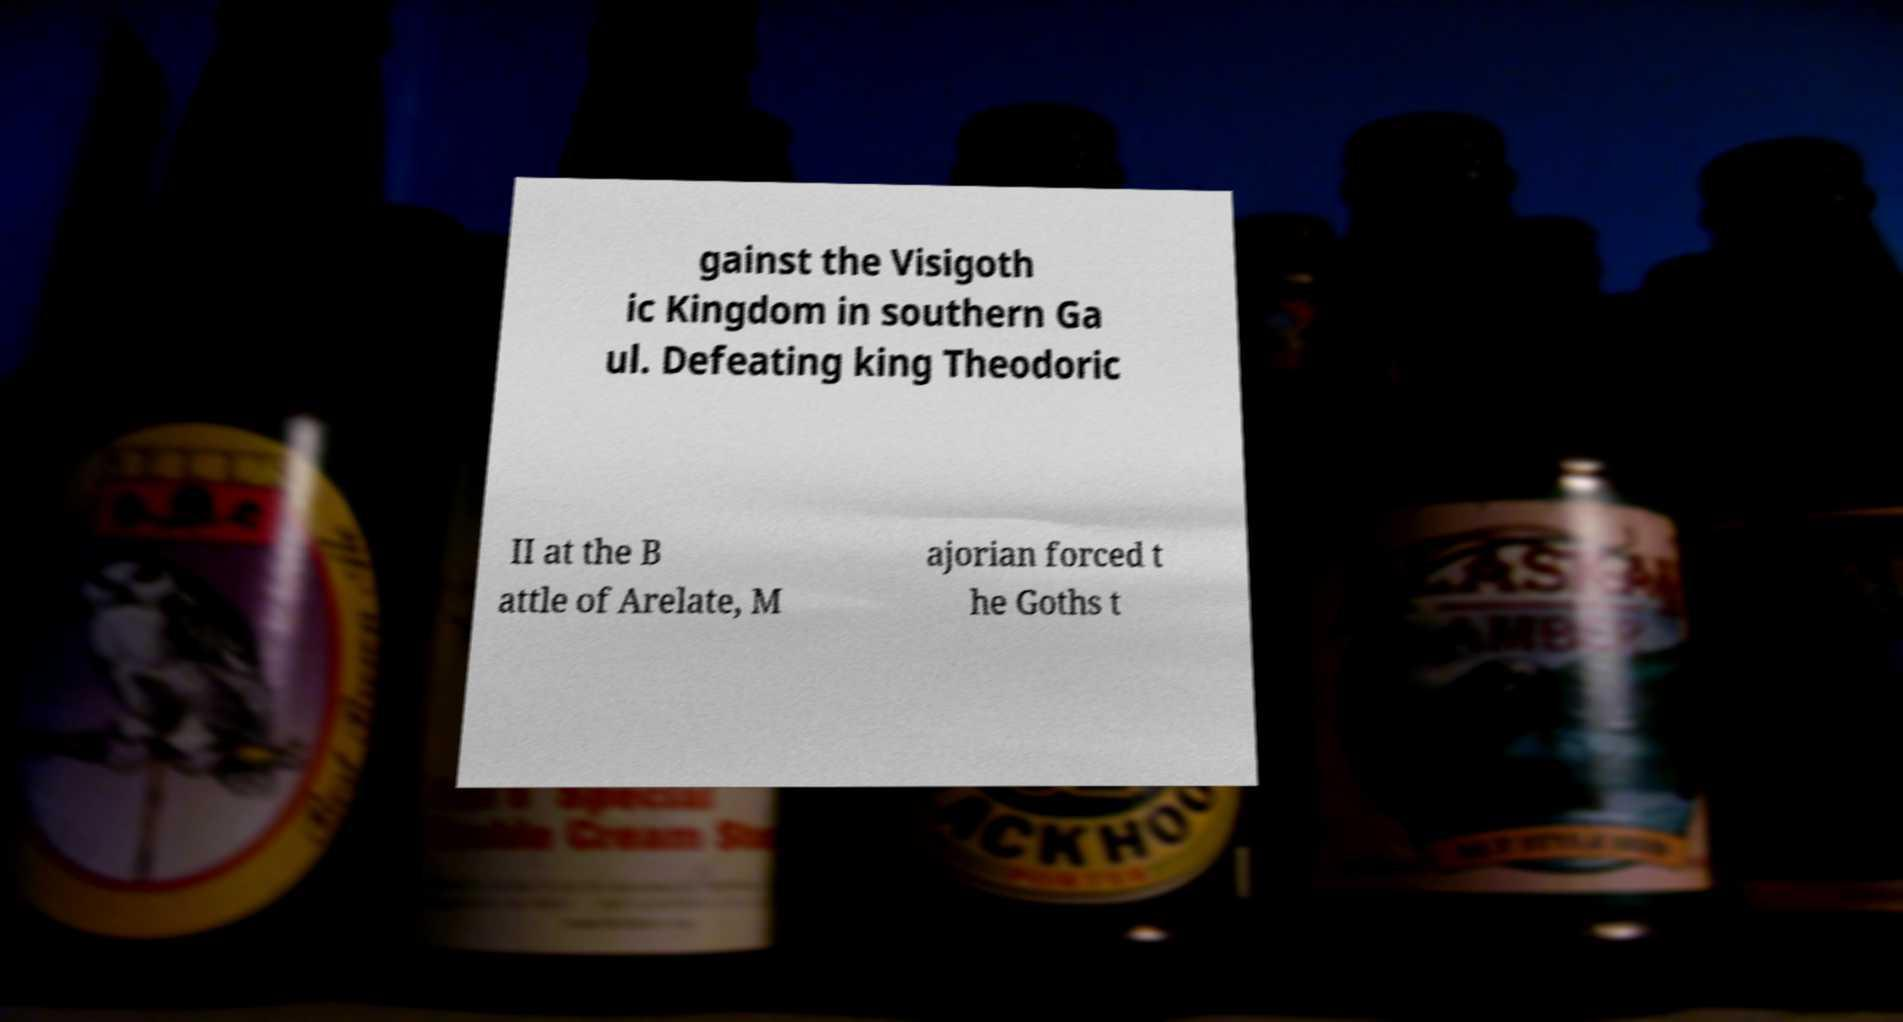Please read and relay the text visible in this image. What does it say? gainst the Visigoth ic Kingdom in southern Ga ul. Defeating king Theodoric II at the B attle of Arelate, M ajorian forced t he Goths t 